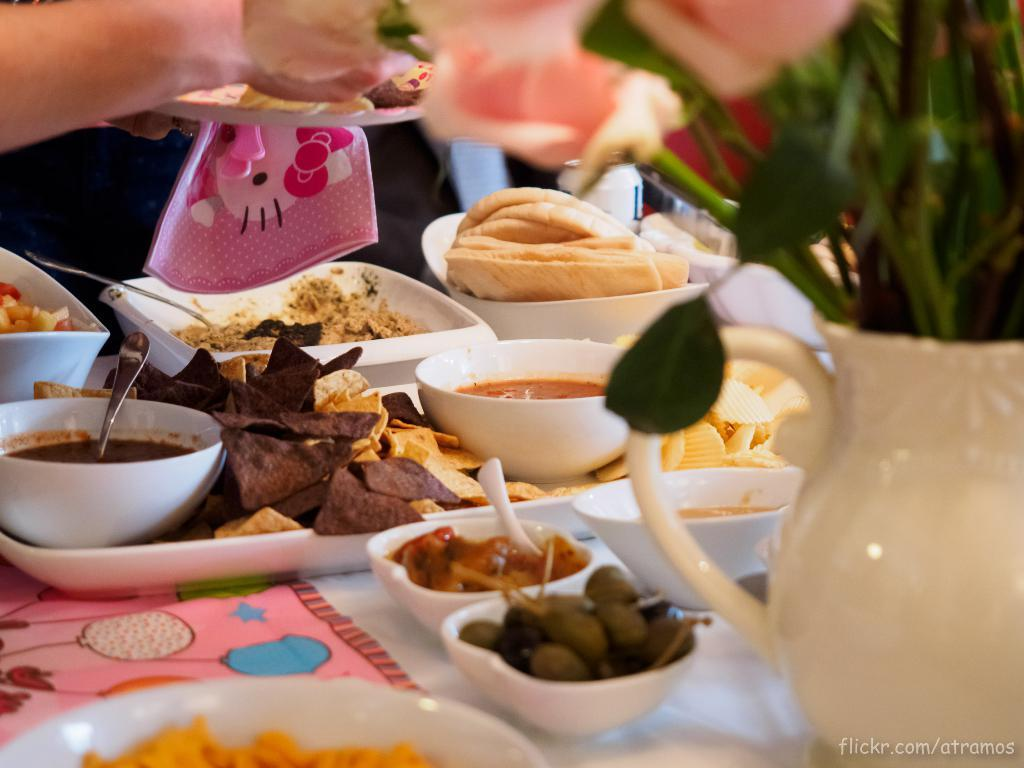What piece of furniture is present in the image? There is a table in the image. What objects are placed on the table? There are plates and bowls on the table. What is contained within the plates and bowls? There is food in the plates and bowls. What type of vegetation is near the table? There is a plant next to the table. Can you tell me what type of toy is being used by the queen in the image? There is no queen or toy present in the image. The image features a table with plates, bowls, food, and a plant. 